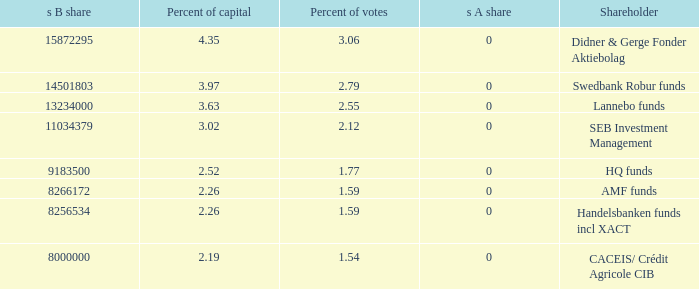Could you help me parse every detail presented in this table? {'header': ['s B share', 'Percent of capital', 'Percent of votes', 's A share', 'Shareholder'], 'rows': [['15872295', '4.35', '3.06', '0', 'Didner & Gerge Fonder Aktiebolag'], ['14501803', '3.97', '2.79', '0', 'Swedbank Robur funds'], ['13234000', '3.63', '2.55', '0', 'Lannebo funds'], ['11034379', '3.02', '2.12', '0', 'SEB Investment Management'], ['9183500', '2.52', '1.77', '0', 'HQ funds'], ['8266172', '2.26', '1.59', '0', 'AMF funds'], ['8256534', '2.26', '1.59', '0', 'Handelsbanken funds incl XACT'], ['8000000', '2.19', '1.54', '0', 'CACEIS/ Crédit Agricole CIB']]} What shareholder has 3.63 percent of capital?  Lannebo funds. 